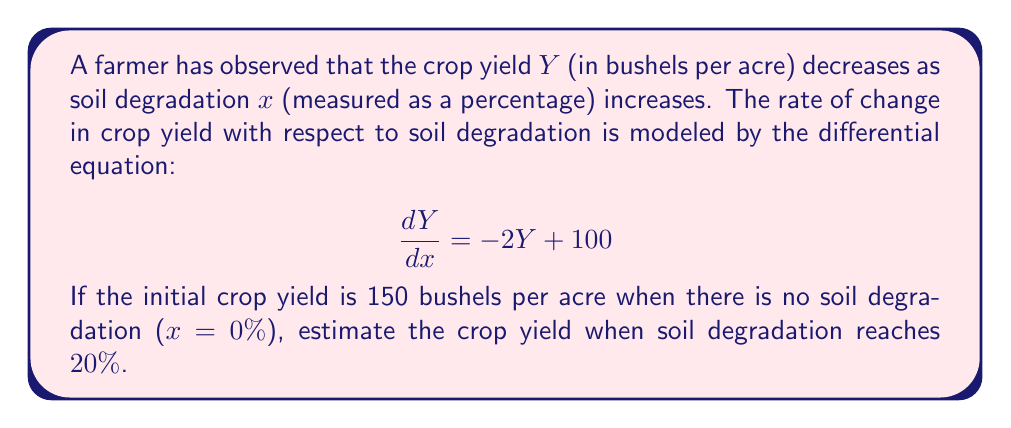Show me your answer to this math problem. To solve this problem, we need to follow these steps:

1) First, we recognize this as a first-order linear differential equation in the form:

   $$\frac{dY}{dx} + P(x)Y = Q(x)$$

   where $P(x) = 2$ and $Q(x) = 100$

2) The general solution for this type of equation is:

   $$Y = e^{-\int P(x)dx} \left(\int Q(x)e^{\int P(x)dx}dx + C\right)$$

3) Let's solve each part:
   
   $\int P(x)dx = \int 2dx = 2x$
   
   $e^{\int P(x)dx} = e^{2x}$
   
   $\int Q(x)e^{\int P(x)dx}dx = \int 100e^{2x}dx = 50e^{2x} + C_1$

4) Substituting these back into the general solution:

   $$Y = e^{-2x}(50e^{2x} + C) = 50 + Ce^{-2x}$$

5) Now we use the initial condition: $Y(0) = 150$
   
   $150 = 50 + C$
   $C = 100$

6) So our particular solution is:

   $$Y = 50 + 100e^{-2x}$$

7) To find the crop yield at 20% soil degradation, we substitute $x = 0.2$:

   $$Y(0.2) = 50 + 100e^{-2(0.2)} = 50 + 100e^{-0.4}$$

8) Calculating this:

   $$Y(0.2) = 50 + 100(0.6703) = 117.03$$

Therefore, when soil degradation reaches 20%, the estimated crop yield is approximately 117.03 bushels per acre.
Answer: The estimated crop yield when soil degradation reaches 20% is approximately 117.03 bushels per acre. 